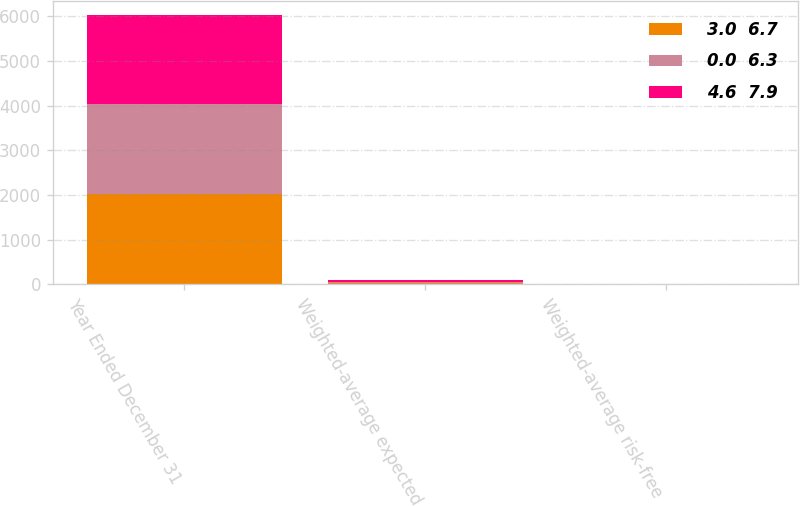<chart> <loc_0><loc_0><loc_500><loc_500><stacked_bar_chart><ecel><fcel>Year Ended December 31<fcel>Weighted-average expected<fcel>Weighted-average risk-free<nl><fcel>3.0  6.7<fcel>2013<fcel>28<fcel>2.5<nl><fcel>0.0  6.3<fcel>2012<fcel>31<fcel>1.8<nl><fcel>4.6  7.9<fcel>2011<fcel>36<fcel>2.1<nl></chart> 